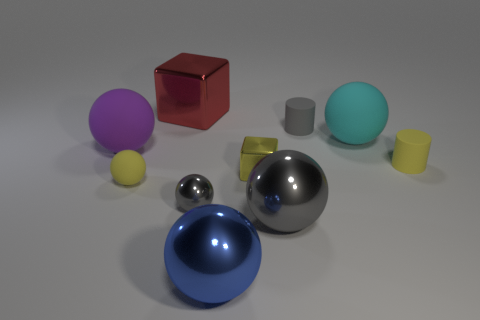Subtract all tiny spheres. How many spheres are left? 4 Subtract 3 balls. How many balls are left? 3 Subtract all cyan spheres. How many spheres are left? 5 Subtract all green spheres. Subtract all brown blocks. How many spheres are left? 6 Subtract all blocks. How many objects are left? 8 Subtract 0 green balls. How many objects are left? 10 Subtract all matte things. Subtract all yellow matte spheres. How many objects are left? 4 Add 8 large red objects. How many large red objects are left? 9 Add 1 brown shiny balls. How many brown shiny balls exist? 1 